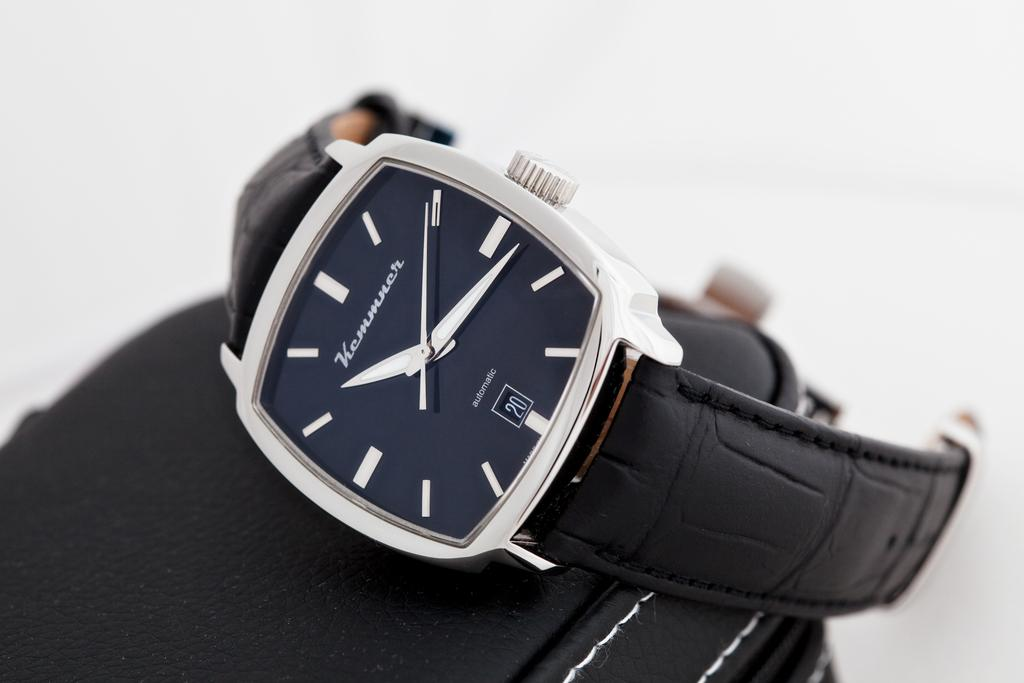Provide a one-sentence caption for the provided image. A watch with a leather band by Kemmner. 